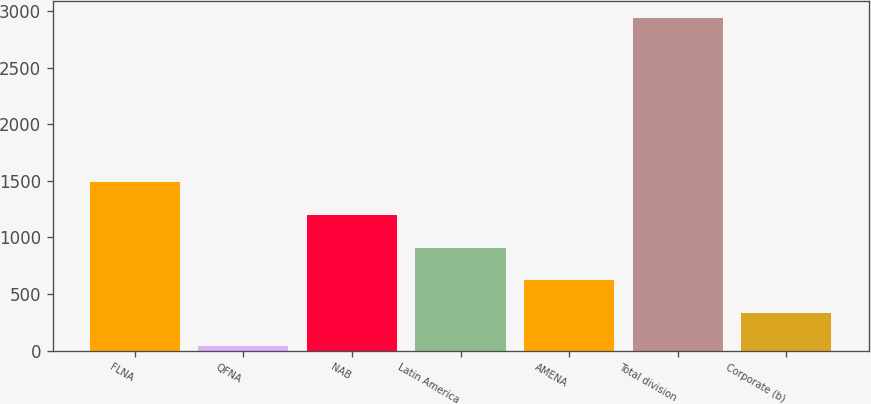<chart> <loc_0><loc_0><loc_500><loc_500><bar_chart><fcel>FLNA<fcel>QFNA<fcel>NAB<fcel>Latin America<fcel>AMENA<fcel>Total division<fcel>Corporate (b)<nl><fcel>1489.5<fcel>41<fcel>1199.8<fcel>910.1<fcel>620.4<fcel>2938<fcel>330.7<nl></chart> 